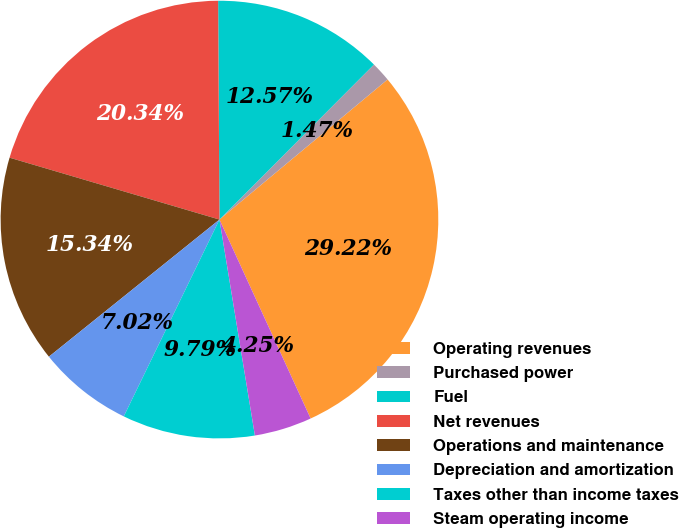Convert chart. <chart><loc_0><loc_0><loc_500><loc_500><pie_chart><fcel>Operating revenues<fcel>Purchased power<fcel>Fuel<fcel>Net revenues<fcel>Operations and maintenance<fcel>Depreciation and amortization<fcel>Taxes other than income taxes<fcel>Steam operating income<nl><fcel>29.22%<fcel>1.47%<fcel>12.57%<fcel>20.34%<fcel>15.34%<fcel>7.02%<fcel>9.79%<fcel>4.25%<nl></chart> 